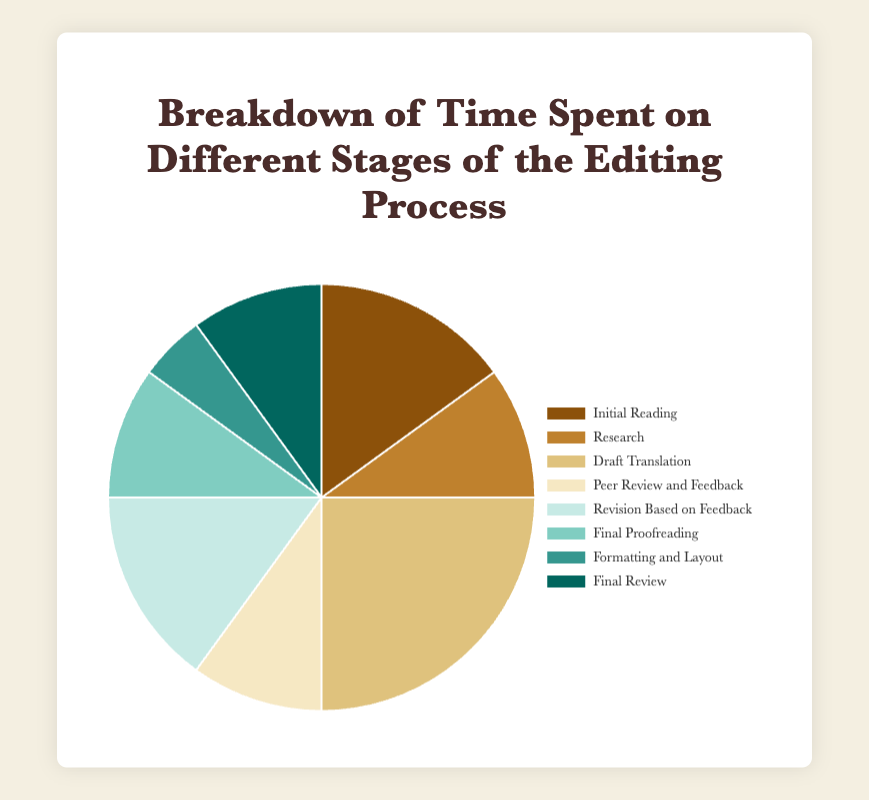Which stage takes the largest percentage of time? The stage that takes the largest percentage can be identified by looking at the segment with the largest area in the pie chart. The "Draft Translation" stage takes 25%, which is higher than any other stage.
Answer: Draft Translation Which two stages combined take up 30% of the time spent on the editing process? To find a combination of two stages that sum to 30%, look for pairs of percentages that add up to 30. "Initial Reading" is 15% and "Revision Based on Feedback" is also 15%. Adding them together gives 15 + 15 = 30.
Answer: Initial Reading and Revision Based on Feedback Which stage takes the same amount of time as Final Review? To identify the stage with the same percentage as Final Review (10%), find another segment labeled with 10% in the pie chart. "Research," "Peer Review and Feedback," and "Final Proofreading" all take 10%, just like "Final Review."
Answer: Research, Peer Review and Feedback, and Final Proofreading By how much is the time spent on Draft Translation greater than that on Formatting and Layout? Subtract the percentage of "Formatting and Layout" from that of "Draft Translation". Draft Translation (25%) - Formatting and Layout (5%) = 25 - 5 = 20.
Answer: 20% What is the total percentage of time spent on Final Tasks (Final Proofreading, Formatting and Layout, Final Review)? Add the percentages of Final Proofreading (10%), Formatting and Layout (5%), and Final Review (10%). 10 + 5 + 10 = 25%.
Answer: 25% What is the average percentage of time spent on stages related to feedback (Peer Review and Feedback, and Revision Based on Feedback)? Add the percentages of Peer Review and Feedback (10%) and Revision Based on Feedback (15%), then divide by the number of stages. (10 + 15) / 2 = 25 / 2 = 12.5%.
Answer: 12.5% Which stage, represented by a blue segment, takes 10% of the time? Identify the segment colored blue and check the corresponding label listed in the legend. Among the stages taking 10%, "Final Proofreading" has a blue segment.
Answer: Final Proofreading Which two stages together take up a quarter (25%) of the total time spent on the editing process? A quarter of 100% is 25%. Find two stages whose percentages sum up to 25%. "Initial Reading" (15%) and "Research" (10%) together sum to 15 + 10 = 25%.
Answer: Initial Reading and Research 